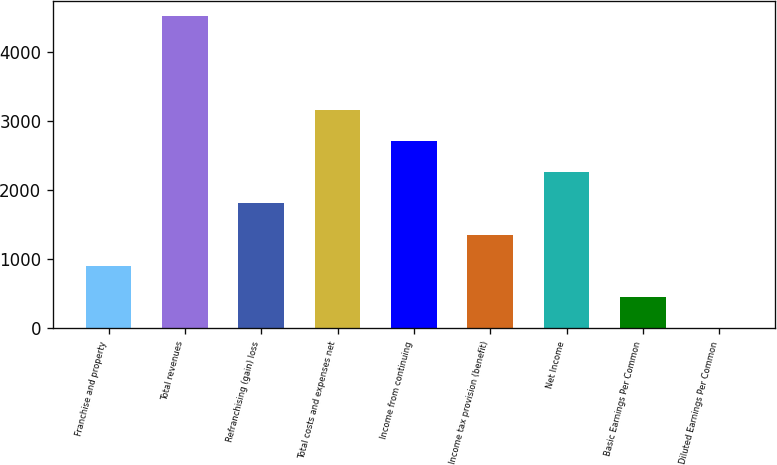<chart> <loc_0><loc_0><loc_500><loc_500><bar_chart><fcel>Franchise and property<fcel>Total revenues<fcel>Refranchising (gain) loss<fcel>Total costs and expenses net<fcel>Income from continuing<fcel>Income tax provision (benefit)<fcel>Net Income<fcel>Basic Earnings Per Common<fcel>Diluted Earnings Per Common<nl><fcel>908.78<fcel>4525<fcel>1812.84<fcel>3168.93<fcel>2716.9<fcel>1360.81<fcel>2264.87<fcel>456.75<fcel>4.72<nl></chart> 